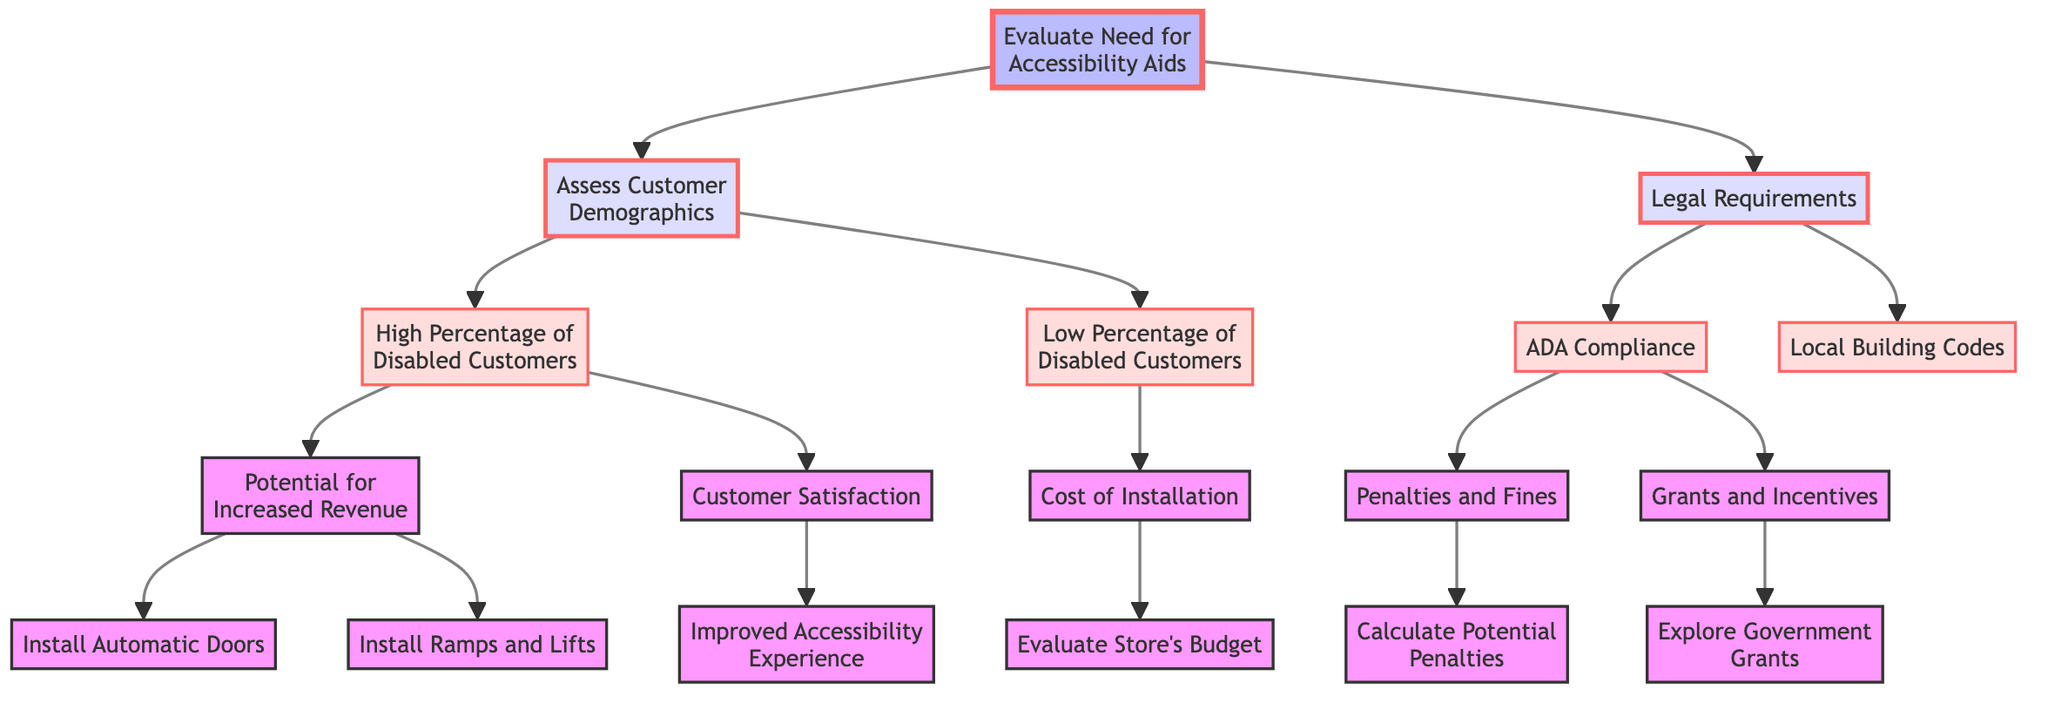What is the title of the diagram? The title of the diagram is prominently displayed at the top and states the subject matter addressed by the decision tree.
Answer: Cost-Benefit Analysis of Installing Accessibility Aids How many main categories are there under "Evaluate Need for Accessibility Aids"? The decision tree has two main categories branching from the first node: "Assess Customer Demographics" and "Legal Requirements".
Answer: 2 What is the consequence of "ADA Compliance"? This node leads to "Penalties and Fines," indicating the potential consequences of non-compliance with ADA standards.
Answer: Penalties and Fines What type of installation can be pursued if there is a "High Percentage of Disabled Customers"? The node indicates that one option is to "Install Automatic Doors," which suggests a direct response to meet the needs of a significant disabled customer base.
Answer: Install Automatic Doors What follows "Cost of Installation"? The further node under "Cost of Installation" directs to "Evaluate Store's Budget," indicating the financial aspect after assessing installation costs.
Answer: Evaluate Store's Budget What happens when exploring "Government Grants"? The node mentions "Explore Government Grants" which leads to "Explore Government Grants," displaying the possibility of financial support for accessibility improvements.
Answer: Explore Government Grants What can lead to "Improved Accessibility Experience"? The tree shows that "Customer Satisfaction" has a link to "Improved Accessibility Experience," highlighting the positive outcomes associated with increased accessibility.
Answer: Improved Accessibility Experience What do legal codes relate to in this diagram? "Local Building Codes" is a part of the legal requirements section, indicating another layer of regulations that must be considered for installation.
Answer: Local Building Codes Which installation option is focused on increasing revenue? "Install Ramps and Lifts" is one of the options under the potential for increased revenue, presenting another method of addressing customer needs.
Answer: Install Ramps and Lifts 